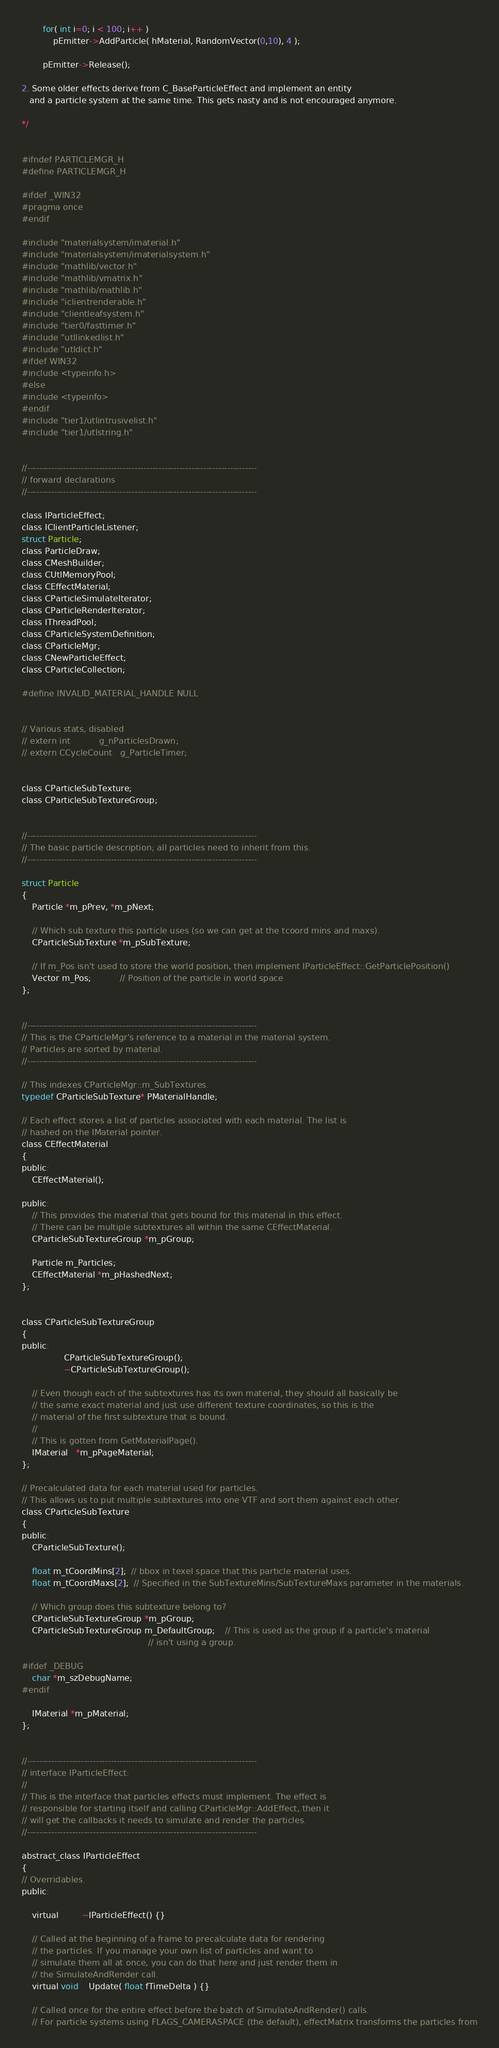Convert code to text. <code><loc_0><loc_0><loc_500><loc_500><_C_>
        for( int i=0; i < 100; i++ )
            pEmitter->AddParticle( hMaterial, RandomVector(0,10), 4 );

        pEmitter->Release();

2. Some older effects derive from C_BaseParticleEffect and implement an entity
   and a particle system at the same time. This gets nasty and is not encouraged anymore.

*/


#ifndef PARTICLEMGR_H
#define PARTICLEMGR_H

#ifdef _WIN32
#pragma once
#endif

#include "materialsystem/imaterial.h"
#include "materialsystem/imaterialsystem.h"
#include "mathlib/vector.h"
#include "mathlib/vmatrix.h"
#include "mathlib/mathlib.h"
#include "iclientrenderable.h"
#include "clientleafsystem.h"
#include "tier0/fasttimer.h"
#include "utllinkedlist.h"
#include "utldict.h"
#ifdef WIN32
#include <typeinfo.h>
#else
#include <typeinfo>
#endif
#include "tier1/utlintrusivelist.h"
#include "tier1/utlstring.h"


//-----------------------------------------------------------------------------
// forward declarations
//-----------------------------------------------------------------------------

class IParticleEffect;
class IClientParticleListener;
struct Particle;
class ParticleDraw;
class CMeshBuilder;
class CUtlMemoryPool;
class CEffectMaterial;
class CParticleSimulateIterator;
class CParticleRenderIterator;
class IThreadPool;
class CParticleSystemDefinition;
class CParticleMgr;
class CNewParticleEffect;
class CParticleCollection;

#define INVALID_MATERIAL_HANDLE NULL


// Various stats, disabled
// extern int           g_nParticlesDrawn;
// extern CCycleCount   g_ParticleTimer;


class CParticleSubTexture;
class CParticleSubTextureGroup;


//-----------------------------------------------------------------------------
// The basic particle description; all particles need to inherit from this.
//-----------------------------------------------------------------------------

struct Particle
{
    Particle *m_pPrev, *m_pNext;

    // Which sub texture this particle uses (so we can get at the tcoord mins and maxs).
    CParticleSubTexture *m_pSubTexture;

    // If m_Pos isn't used to store the world position, then implement IParticleEffect::GetParticlePosition()
    Vector m_Pos;           // Position of the particle in world space
};


//-----------------------------------------------------------------------------
// This is the CParticleMgr's reference to a material in the material system.
// Particles are sorted by material.
//-----------------------------------------------------------------------------

// This indexes CParticleMgr::m_SubTextures.
typedef CParticleSubTexture* PMaterialHandle;

// Each effect stores a list of particles associated with each material. The list is
// hashed on the IMaterial pointer.
class CEffectMaterial
{
public:
    CEffectMaterial();

public:
    // This provides the material that gets bound for this material in this effect.
    // There can be multiple subtextures all within the same CEffectMaterial.
    CParticleSubTextureGroup *m_pGroup;

    Particle m_Particles;
    CEffectMaterial *m_pHashedNext;
};


class CParticleSubTextureGroup
{
public:
                CParticleSubTextureGroup();
                ~CParticleSubTextureGroup();

    // Even though each of the subtextures has its own material, they should all basically be
    // the same exact material and just use different texture coordinates, so this is the
    // material of the first subtexture that is bound.
    //
    // This is gotten from GetMaterialPage().
    IMaterial   *m_pPageMaterial;
};

// Precalculated data for each material used for particles.
// This allows us to put multiple subtextures into one VTF and sort them against each other.
class CParticleSubTexture
{
public:
    CParticleSubTexture();

    float m_tCoordMins[2];  // bbox in texel space that this particle material uses.
    float m_tCoordMaxs[2];  // Specified in the SubTextureMins/SubTextureMaxs parameter in the materials.

    // Which group does this subtexture belong to?
    CParticleSubTextureGroup *m_pGroup;
    CParticleSubTextureGroup m_DefaultGroup;    // This is used as the group if a particle's material
                                                // isn't using a group.

#ifdef _DEBUG
    char *m_szDebugName;
#endif

    IMaterial *m_pMaterial;
};


//-----------------------------------------------------------------------------
// interface IParticleEffect:
//
// This is the interface that particles effects must implement. The effect is
// responsible for starting itself and calling CParticleMgr::AddEffect, then it
// will get the callbacks it needs to simulate and render the particles.
//-----------------------------------------------------------------------------

abstract_class IParticleEffect
{
// Overridables.
public:

    virtual         ~IParticleEffect() {}

    // Called at the beginning of a frame to precalculate data for rendering
    // the particles. If you manage your own list of particles and want to
    // simulate them all at once, you can do that here and just render them in
    // the SimulateAndRender call.
    virtual void    Update( float fTimeDelta ) {}

    // Called once for the entire effect before the batch of SimulateAndRender() calls.
    // For particle systems using FLAGS_CAMERASPACE (the default), effectMatrix transforms the particles from</code> 